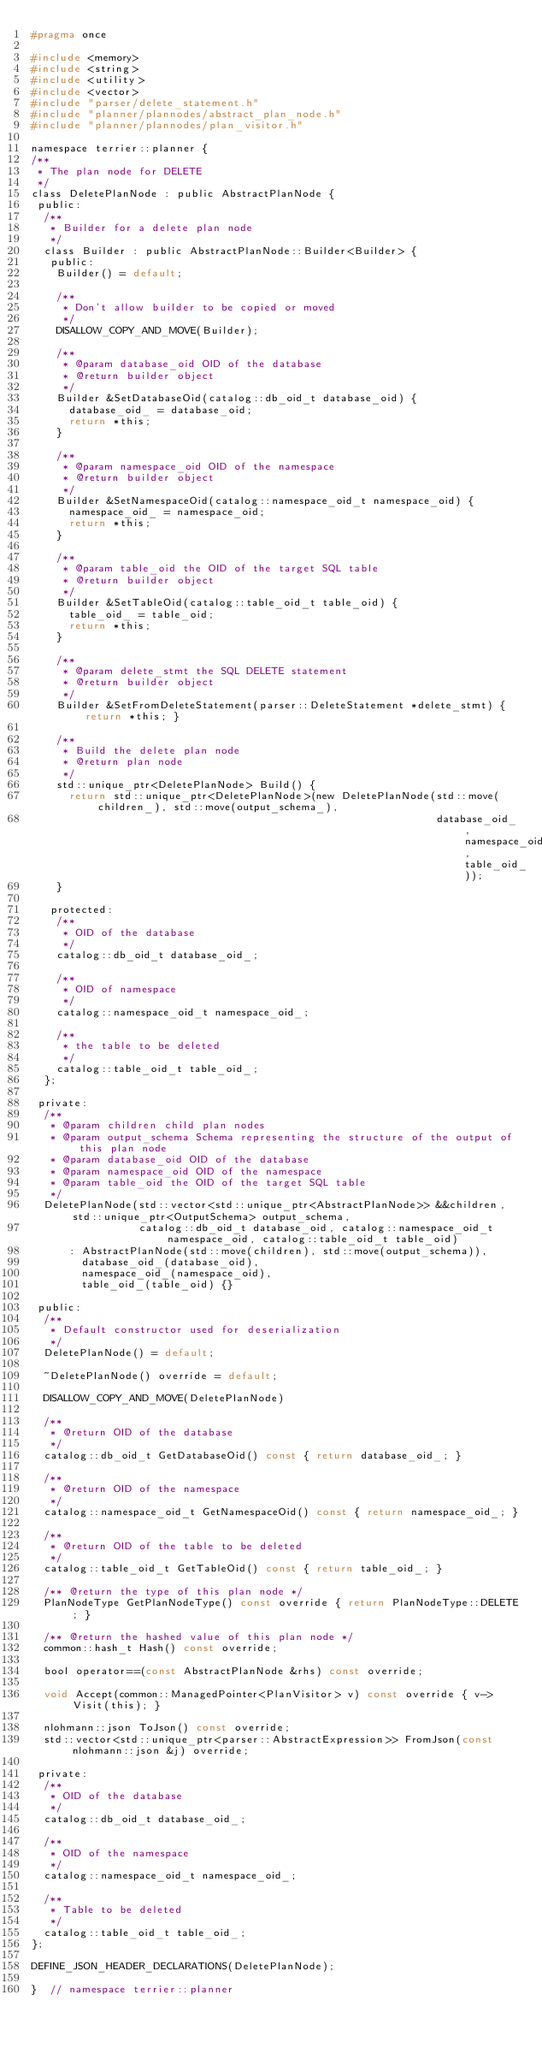<code> <loc_0><loc_0><loc_500><loc_500><_C_>#pragma once

#include <memory>
#include <string>
#include <utility>
#include <vector>
#include "parser/delete_statement.h"
#include "planner/plannodes/abstract_plan_node.h"
#include "planner/plannodes/plan_visitor.h"

namespace terrier::planner {
/**
 * The plan node for DELETE
 */
class DeletePlanNode : public AbstractPlanNode {
 public:
  /**
   * Builder for a delete plan node
   */
  class Builder : public AbstractPlanNode::Builder<Builder> {
   public:
    Builder() = default;

    /**
     * Don't allow builder to be copied or moved
     */
    DISALLOW_COPY_AND_MOVE(Builder);

    /**
     * @param database_oid OID of the database
     * @return builder object
     */
    Builder &SetDatabaseOid(catalog::db_oid_t database_oid) {
      database_oid_ = database_oid;
      return *this;
    }

    /**
     * @param namespace_oid OID of the namespace
     * @return builder object
     */
    Builder &SetNamespaceOid(catalog::namespace_oid_t namespace_oid) {
      namespace_oid_ = namespace_oid;
      return *this;
    }

    /**
     * @param table_oid the OID of the target SQL table
     * @return builder object
     */
    Builder &SetTableOid(catalog::table_oid_t table_oid) {
      table_oid_ = table_oid;
      return *this;
    }

    /**
     * @param delete_stmt the SQL DELETE statement
     * @return builder object
     */
    Builder &SetFromDeleteStatement(parser::DeleteStatement *delete_stmt) { return *this; }

    /**
     * Build the delete plan node
     * @return plan node
     */
    std::unique_ptr<DeletePlanNode> Build() {
      return std::unique_ptr<DeletePlanNode>(new DeletePlanNode(std::move(children_), std::move(output_schema_),
                                                                database_oid_, namespace_oid_, table_oid_));
    }

   protected:
    /**
     * OID of the database
     */
    catalog::db_oid_t database_oid_;

    /**
     * OID of namespace
     */
    catalog::namespace_oid_t namespace_oid_;

    /**
     * the table to be deleted
     */
    catalog::table_oid_t table_oid_;
  };

 private:
  /**
   * @param children child plan nodes
   * @param output_schema Schema representing the structure of the output of this plan node
   * @param database_oid OID of the database
   * @param namespace_oid OID of the namespace
   * @param table_oid the OID of the target SQL table
   */
  DeletePlanNode(std::vector<std::unique_ptr<AbstractPlanNode>> &&children, std::unique_ptr<OutputSchema> output_schema,
                 catalog::db_oid_t database_oid, catalog::namespace_oid_t namespace_oid, catalog::table_oid_t table_oid)
      : AbstractPlanNode(std::move(children), std::move(output_schema)),
        database_oid_(database_oid),
        namespace_oid_(namespace_oid),
        table_oid_(table_oid) {}

 public:
  /**
   * Default constructor used for deserialization
   */
  DeletePlanNode() = default;

  ~DeletePlanNode() override = default;

  DISALLOW_COPY_AND_MOVE(DeletePlanNode)

  /**
   * @return OID of the database
   */
  catalog::db_oid_t GetDatabaseOid() const { return database_oid_; }

  /**
   * @return OID of the namespace
   */
  catalog::namespace_oid_t GetNamespaceOid() const { return namespace_oid_; }

  /**
   * @return OID of the table to be deleted
   */
  catalog::table_oid_t GetTableOid() const { return table_oid_; }

  /** @return the type of this plan node */
  PlanNodeType GetPlanNodeType() const override { return PlanNodeType::DELETE; }

  /** @return the hashed value of this plan node */
  common::hash_t Hash() const override;

  bool operator==(const AbstractPlanNode &rhs) const override;

  void Accept(common::ManagedPointer<PlanVisitor> v) const override { v->Visit(this); }

  nlohmann::json ToJson() const override;
  std::vector<std::unique_ptr<parser::AbstractExpression>> FromJson(const nlohmann::json &j) override;

 private:
  /**
   * OID of the database
   */
  catalog::db_oid_t database_oid_;

  /**
   * OID of the namespace
   */
  catalog::namespace_oid_t namespace_oid_;

  /**
   * Table to be deleted
   */
  catalog::table_oid_t table_oid_;
};

DEFINE_JSON_HEADER_DECLARATIONS(DeletePlanNode);

}  // namespace terrier::planner
</code> 